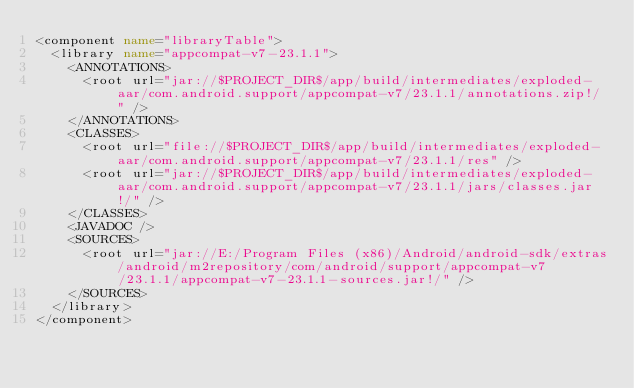<code> <loc_0><loc_0><loc_500><loc_500><_XML_><component name="libraryTable">
  <library name="appcompat-v7-23.1.1">
    <ANNOTATIONS>
      <root url="jar://$PROJECT_DIR$/app/build/intermediates/exploded-aar/com.android.support/appcompat-v7/23.1.1/annotations.zip!/" />
    </ANNOTATIONS>
    <CLASSES>
      <root url="file://$PROJECT_DIR$/app/build/intermediates/exploded-aar/com.android.support/appcompat-v7/23.1.1/res" />
      <root url="jar://$PROJECT_DIR$/app/build/intermediates/exploded-aar/com.android.support/appcompat-v7/23.1.1/jars/classes.jar!/" />
    </CLASSES>
    <JAVADOC />
    <SOURCES>
      <root url="jar://E:/Program Files (x86)/Android/android-sdk/extras/android/m2repository/com/android/support/appcompat-v7/23.1.1/appcompat-v7-23.1.1-sources.jar!/" />
    </SOURCES>
  </library>
</component></code> 